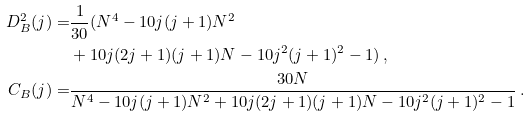Convert formula to latex. <formula><loc_0><loc_0><loc_500><loc_500>D ^ { 2 } _ { B } ( j ) = & \frac { 1 } { 3 0 } ( N ^ { 4 } - 1 0 j ( j + 1 ) N ^ { 2 } \\ & + 1 0 j ( 2 j + 1 ) ( j + 1 ) N - 1 0 j ^ { 2 } ( j + 1 ) ^ { 2 } - 1 ) \, , \\ C _ { B } ( j ) = & \frac { 3 0 N } { N ^ { 4 } - 1 0 j ( j + 1 ) N ^ { 2 } + 1 0 j ( 2 j + 1 ) ( j + 1 ) N - 1 0 j ^ { 2 } ( j + 1 ) ^ { 2 } - 1 } \, .</formula> 